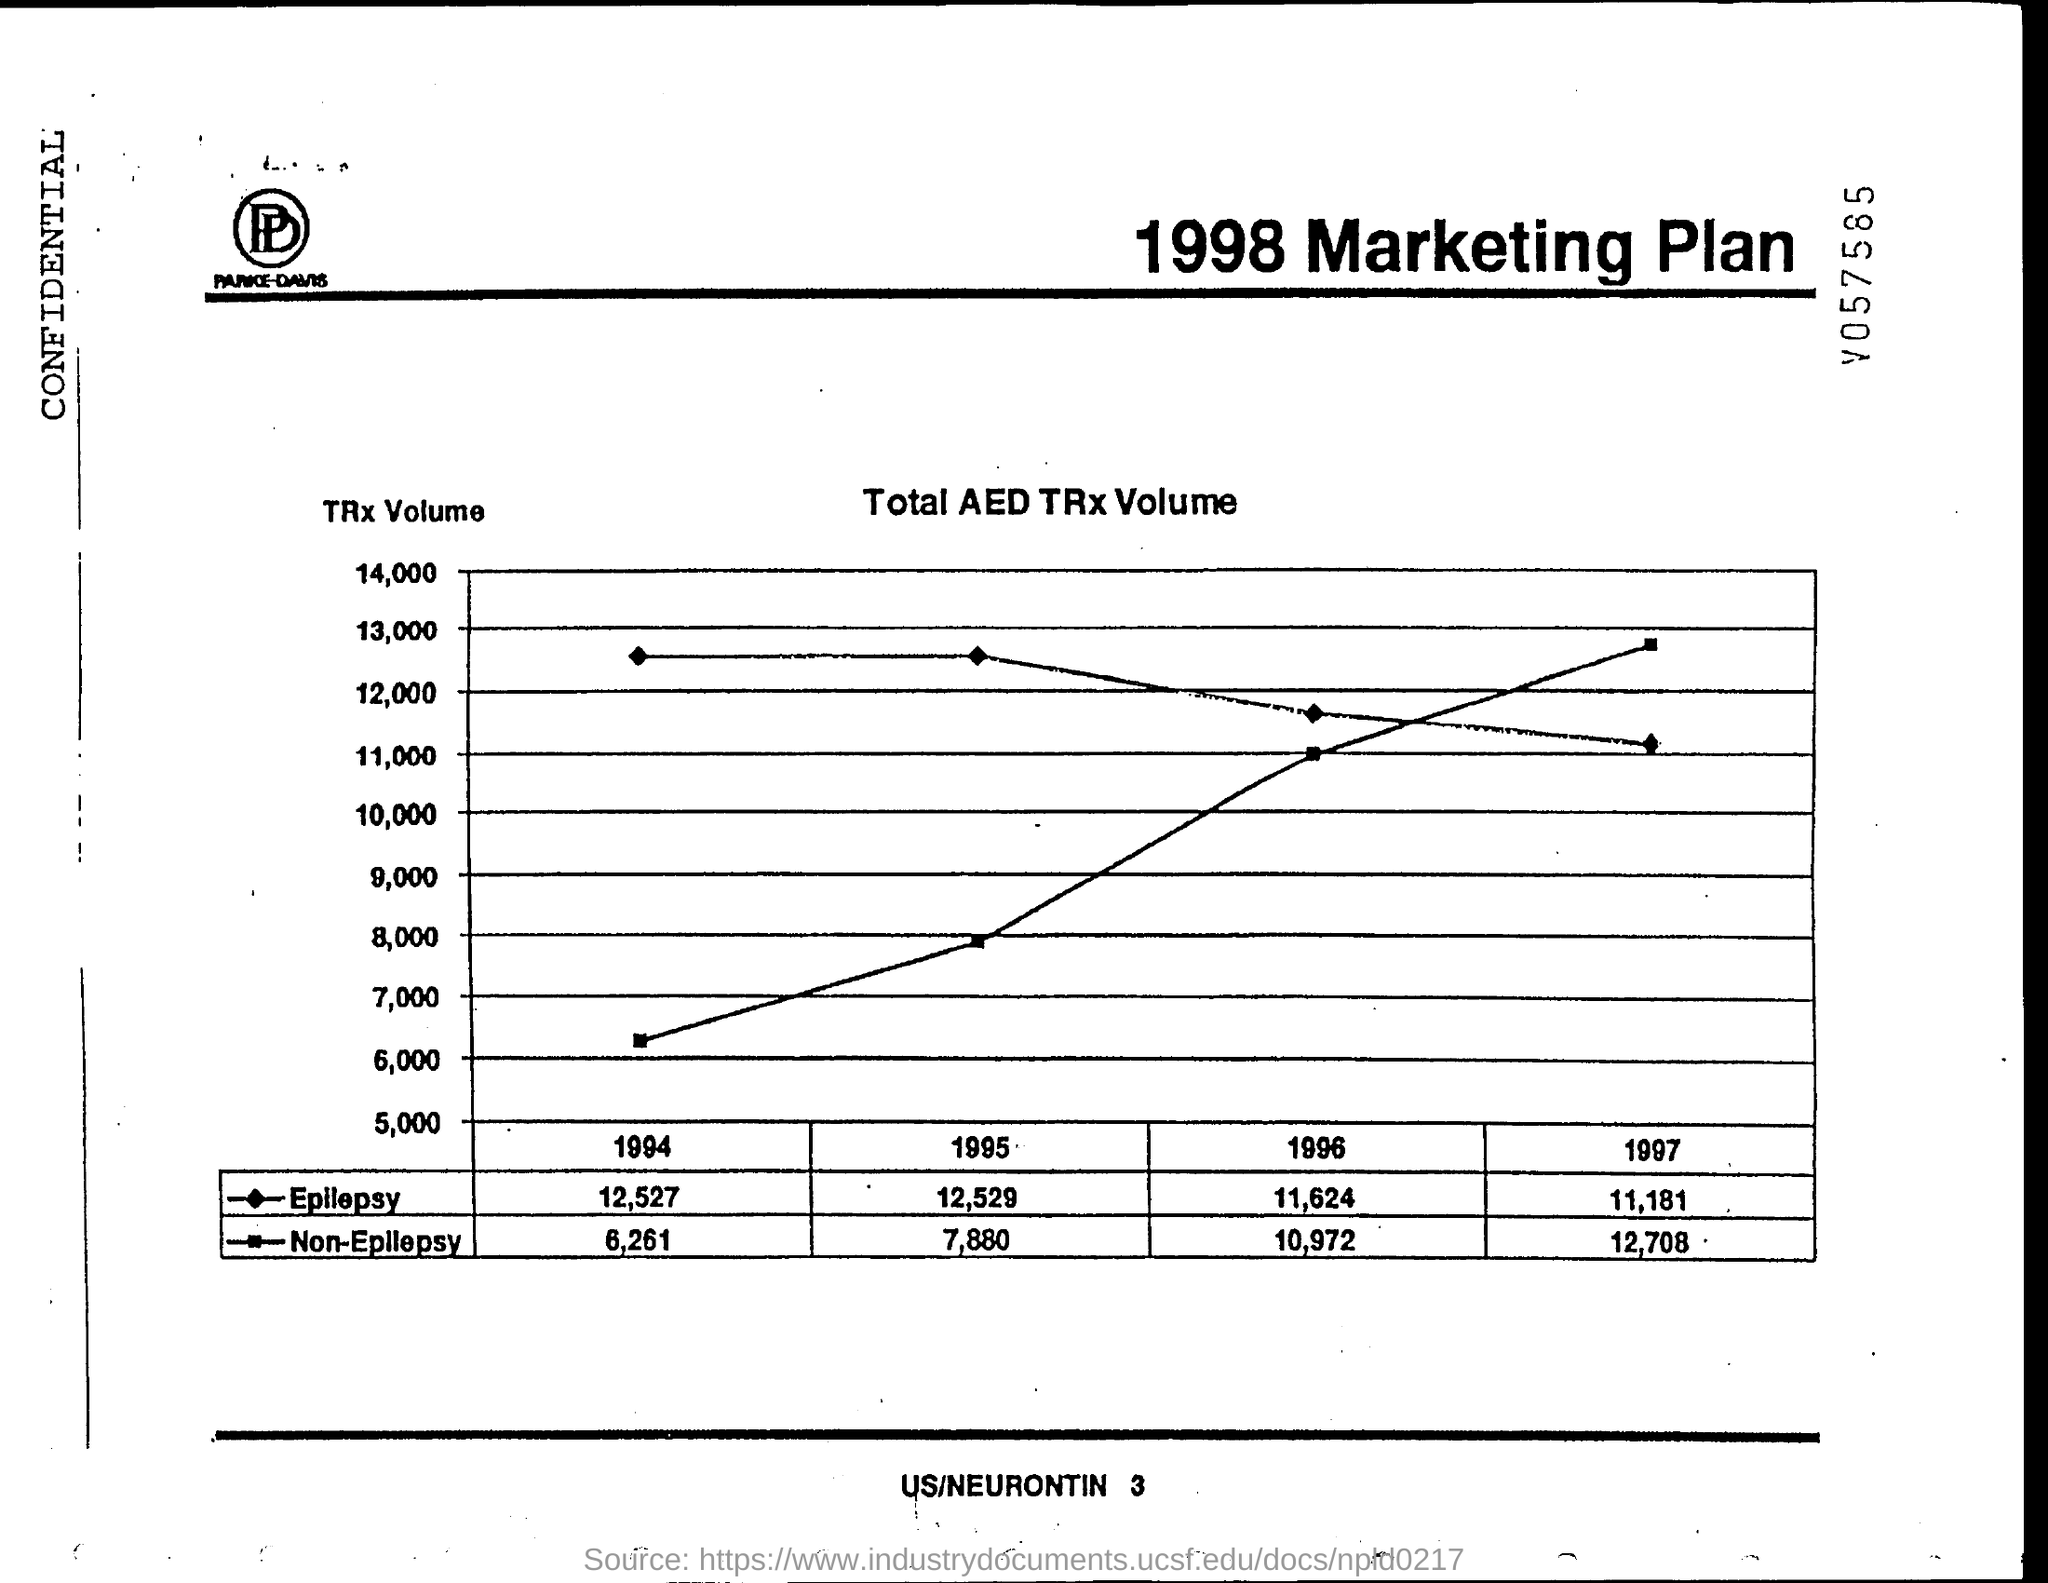Draw attention to some important aspects in this diagram. The total AED TRx volume for non-epilepsy patients in 1994 was 6,261. The total AED transaction volume for epilepsy for the year 1997 was 11,181. The total AED TRx volume for epilepsy in 1994 was 12,527. The total AED transaction volume for non-epilepsy cases in 1997 was 12,708. The total AED TRx volume for non-epilepsy in 1995 was 7,880. 